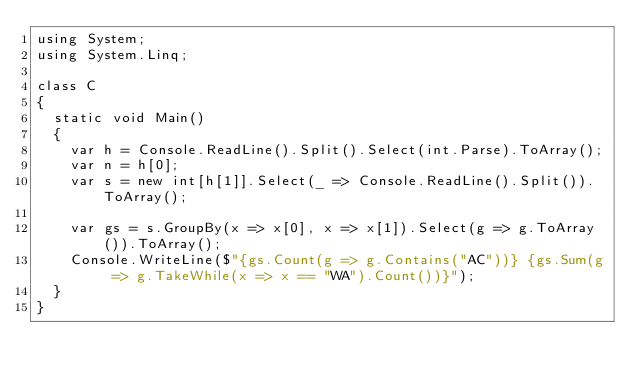<code> <loc_0><loc_0><loc_500><loc_500><_C#_>using System;
using System.Linq;

class C
{
	static void Main()
	{
		var h = Console.ReadLine().Split().Select(int.Parse).ToArray();
		var n = h[0];
		var s = new int[h[1]].Select(_ => Console.ReadLine().Split()).ToArray();

		var gs = s.GroupBy(x => x[0], x => x[1]).Select(g => g.ToArray()).ToArray();
		Console.WriteLine($"{gs.Count(g => g.Contains("AC"))} {gs.Sum(g => g.TakeWhile(x => x == "WA").Count())}");
	}
}
</code> 